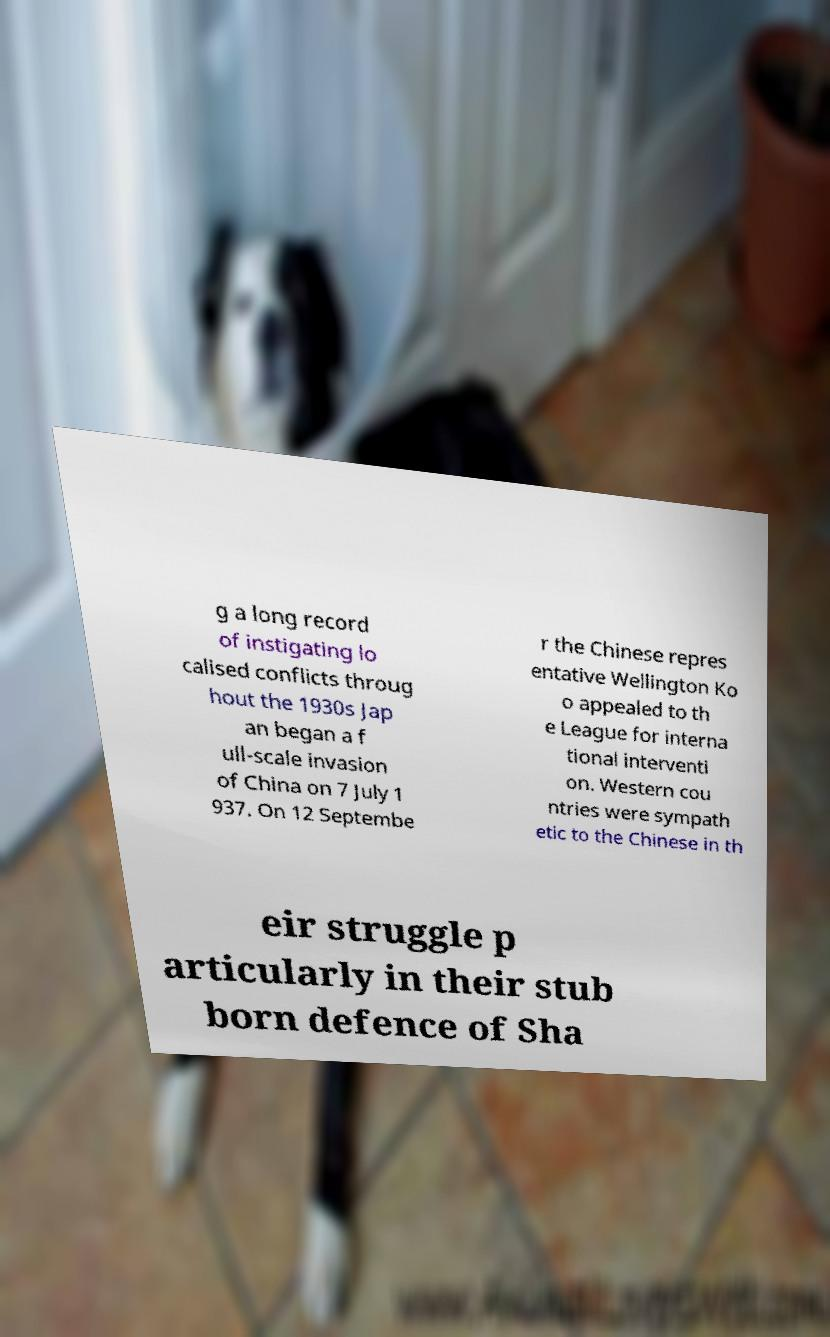For documentation purposes, I need the text within this image transcribed. Could you provide that? g a long record of instigating lo calised conflicts throug hout the 1930s Jap an began a f ull-scale invasion of China on 7 July 1 937. On 12 Septembe r the Chinese repres entative Wellington Ko o appealed to th e League for interna tional interventi on. Western cou ntries were sympath etic to the Chinese in th eir struggle p articularly in their stub born defence of Sha 